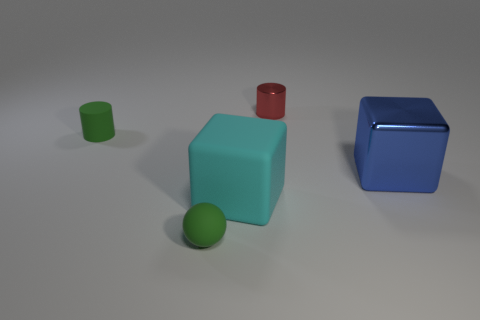What number of cyan things are rubber blocks or big matte cylinders?
Give a very brief answer. 1. Is the number of tiny spheres on the right side of the small red thing less than the number of green spheres?
Provide a succinct answer. Yes. What number of blue things are on the right side of the tiny green object in front of the big shiny thing?
Your answer should be compact. 1. What number of other things are the same size as the blue thing?
Keep it short and to the point. 1. What number of objects are small green matte cylinders or blue shiny cubes that are on the right side of the large cyan matte block?
Offer a terse response. 2. Is the number of large cyan rubber things less than the number of red shiny cubes?
Your answer should be very brief. No. The cylinder on the right side of the tiny green thing in front of the large cyan matte object is what color?
Ensure brevity in your answer.  Red. There is another object that is the same shape as the big metallic object; what is it made of?
Offer a very short reply. Rubber. How many metal objects are either tiny purple cubes or tiny green cylinders?
Your answer should be very brief. 0. Is the material of the cylinder in front of the red shiny cylinder the same as the big object in front of the large metallic block?
Ensure brevity in your answer.  Yes. 